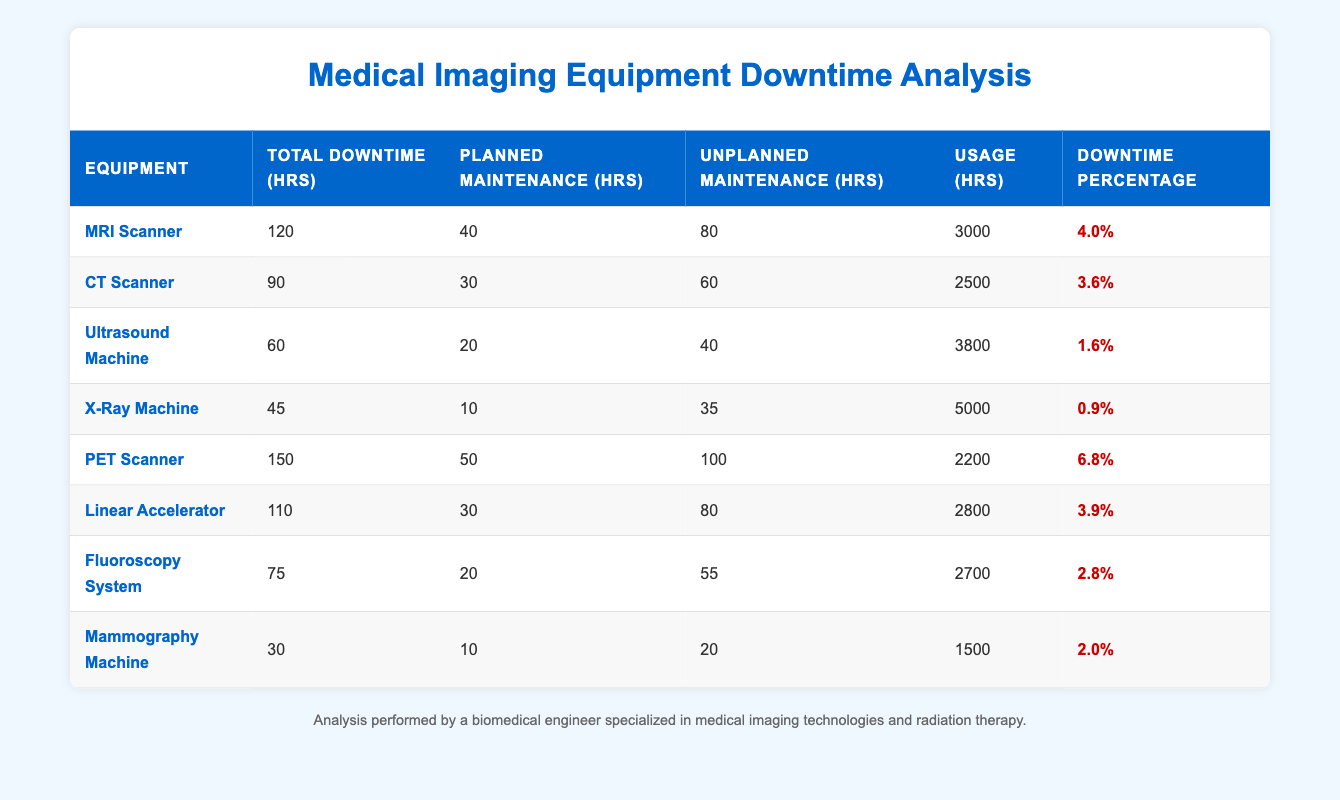What is the total downtime for the X-Ray Machine? The table indicates that the total downtime for the X-Ray Machine is listed directly as 45 hours.
Answer: 45 hours Which piece of equipment undergoes the most unplanned maintenance? By examining the table, the PET Scanner shows 100 hours of unplanned maintenance, which is greater than any other equipment.
Answer: PET Scanner How many hours of planned maintenance does the MRI Scanner require? The table clearly shows that the MRI Scanner requires 40 hours of planned maintenance.
Answer: 40 hours What is the downtime percentage for the Linear Accelerator, and how does it compare to that of the Ultrasound Machine? The Linear Accelerator has a downtime percentage of 3.9%, while the Ultrasound Machine has a downtime percentage of 1.6%. Since 3.9% is greater than 1.6%, the Linear Accelerator has a higher downtime percentage than the Ultrasound Machine.
Answer: 3.9% (Linear Accelerator is higher) If we sum the total downtimes for the three machines with the least downtime, what is the result? The three machines with the least downtime are the Mammography Machine (30 hours), X-Ray Machine (45 hours), and Ultrasound Machine (60 hours). Summing these gives 30 + 45 + 60 = 135 hours.
Answer: 135 hours Is the total downtime for the PET Scanner greater than the combined planned maintenance hours for all machines? Total planned maintenance hours for all machines is 40 + 30 + 20 + 10 + 50 + 30 + 20 + 10 = 210 hours. Since the PET Scanner's total downtime is 150 hours, it is not greater than 210 hours.
Answer: No What is the average downtime percentage across all equipment listed in the table? To find the average, we sum the downtime percentages: 4.0 + 3.6 + 1.6 + 0.9 + 6.8 + 3.9 + 2.8 + 2.0 = 25.6%. Then, we divide this by the number of data points (8): 25.6 / 8 = 3.2%.
Answer: 3.2% Which equipment has the highest downtime percentage and what is the total downtime for that equipment? The PET Scanner has the highest downtime percentage at 6.8%, with a total downtime of 150 hours as indicated in the table.
Answer: PET Scanner, 150 hours How many hours of unplanned maintenance does the Fluoroscopy System require, and what is its total downtime? The Fluoroscopy System requires 55 hours of unplanned maintenance, and its total downtime is 75 hours as shown in the table.
Answer: 55 hours, total downtime 75 hours 